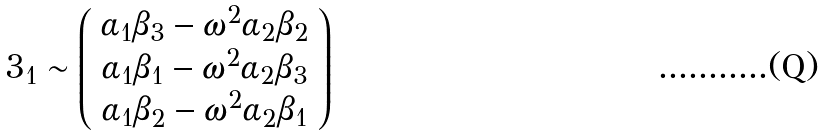Convert formula to latex. <formula><loc_0><loc_0><loc_500><loc_500>3 _ { 1 } \sim \left ( \begin{array} { c } \alpha _ { 1 } \beta _ { 3 } - \omega ^ { 2 } \alpha _ { 2 } \beta _ { 2 } \\ \alpha _ { 1 } \beta _ { 1 } - \omega ^ { 2 } \alpha _ { 2 } \beta _ { 3 } \\ \alpha _ { 1 } \beta _ { 2 } - \omega ^ { 2 } \alpha _ { 2 } \beta _ { 1 } \end{array} \right )</formula> 